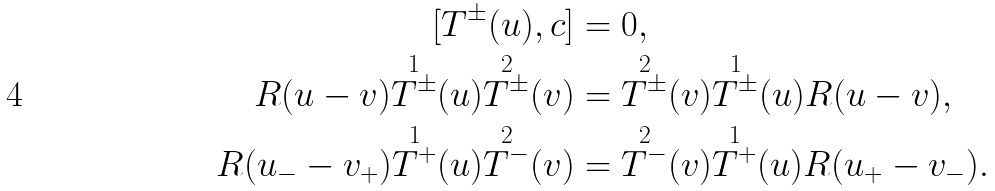Convert formula to latex. <formula><loc_0><loc_0><loc_500><loc_500>[ T ^ { \pm } ( u ) , c ] & = 0 , \\ R ( u - v ) \overset { 1 } { T ^ { \pm } } ( u ) \overset { 2 } { T ^ { \pm } } ( v ) & = \overset { 2 } { T ^ { \pm } } ( v ) \overset { 1 } { T ^ { \pm } } ( u ) R ( u - v ) , \\ R ( u _ { - } - v _ { + } ) \overset { 1 } { T ^ { + } } ( u ) \overset { 2 } { T ^ { - } } ( v ) & = \overset { 2 } { T ^ { - } } ( v ) \overset { 1 } { T ^ { + } } ( u ) R ( u _ { + } - v _ { - } ) .</formula> 